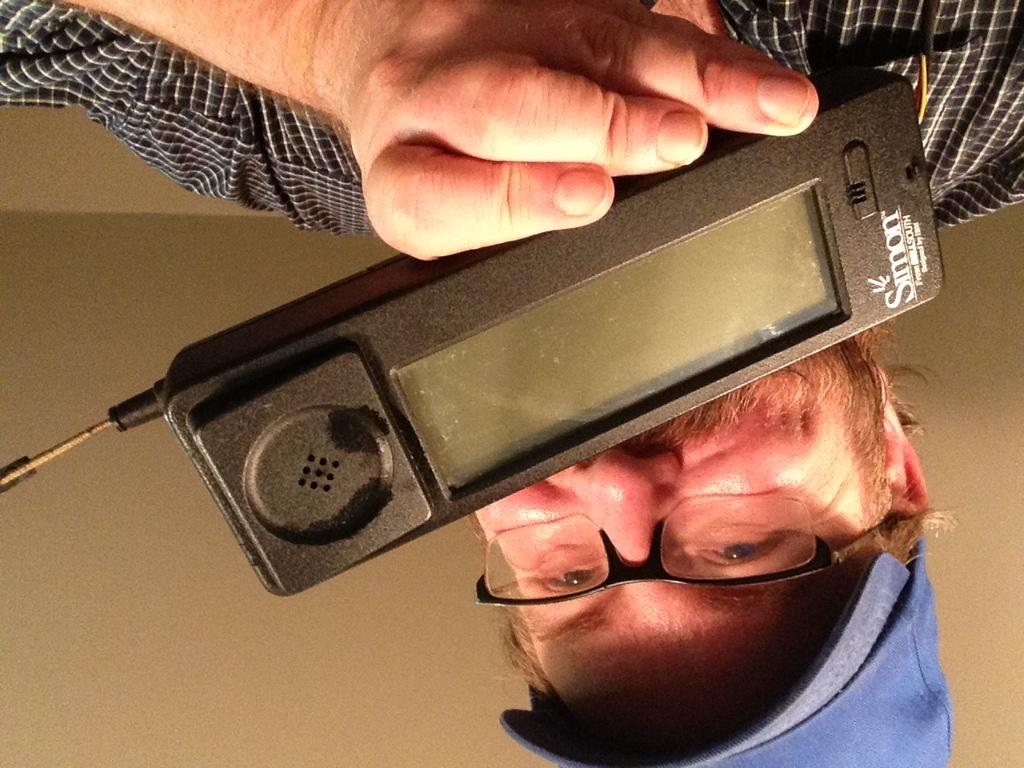What can be seen in the image? There is a person in the image. Can you describe the person's appearance? The person is wearing a blue cap and spectacles. What is the person holding in their hand? The person is holding a phone in their hand. What type of twig is the person holding in their hand? There is no twig present in the image; the person is holding a phone. Can you describe the road the person is walking on in the image? There is no road or walking depicted in the image; the person is stationary. 